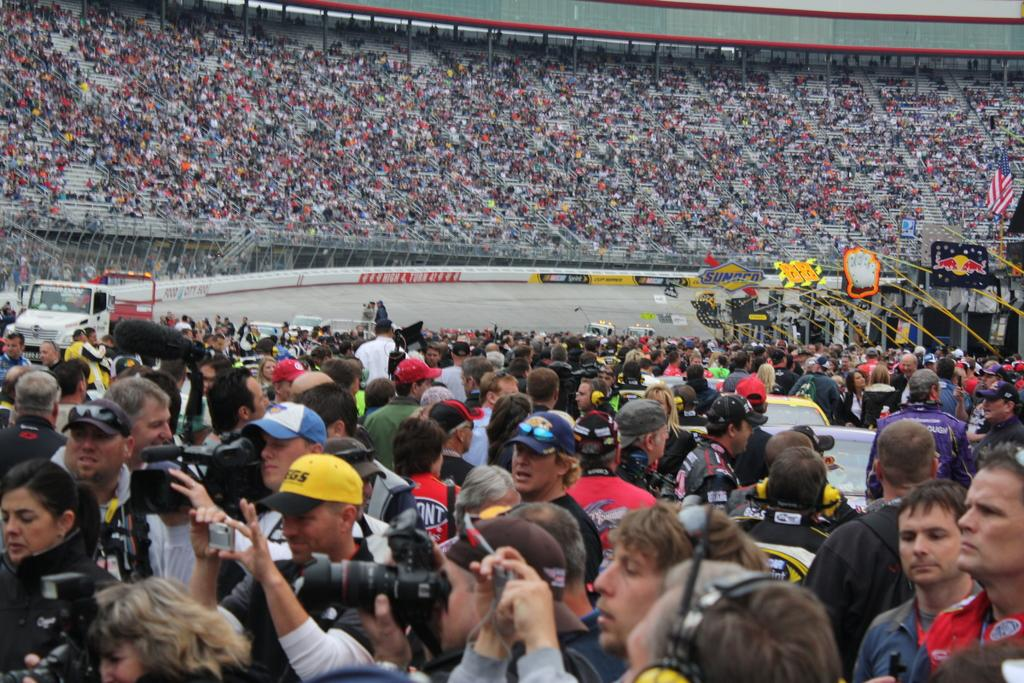What is the man in the image doing? The man is holding a camera and shooting with it. What is the man holding in the image? The man is holding a camera. Are there any other people present in the image? Yes, there are other persons standing in the image. Can you see any steam coming from the camera in the image? There is no steam present in the image. What type of wave is visible in the image? There is no wave visible in the image. 